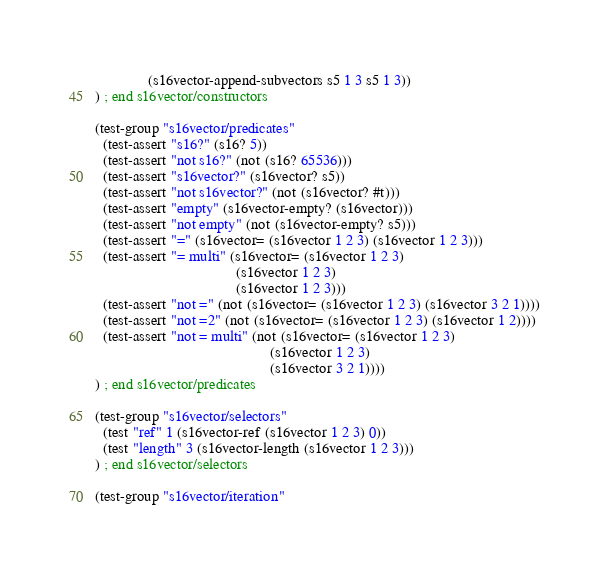Convert code to text. <code><loc_0><loc_0><loc_500><loc_500><_Scheme_>              (s16vector-append-subvectors s5 1 3 s5 1 3))
) ; end s16vector/constructors

(test-group "s16vector/predicates"
  (test-assert "s16?" (s16? 5))
  (test-assert "not s16?" (not (s16? 65536)))
  (test-assert "s16vector?" (s16vector? s5))
  (test-assert "not s16vector?" (not (s16vector? #t)))
  (test-assert "empty" (s16vector-empty? (s16vector)))
  (test-assert "not empty" (not (s16vector-empty? s5)))
  (test-assert "=" (s16vector= (s16vector 1 2 3) (s16vector 1 2 3)))
  (test-assert "= multi" (s16vector= (s16vector 1 2 3)
                                     (s16vector 1 2 3)
                                     (s16vector 1 2 3)))
  (test-assert "not =" (not (s16vector= (s16vector 1 2 3) (s16vector 3 2 1))))
  (test-assert "not =2" (not (s16vector= (s16vector 1 2 3) (s16vector 1 2))))
  (test-assert "not = multi" (not (s16vector= (s16vector 1 2 3)
                                              (s16vector 1 2 3)
                                              (s16vector 3 2 1))))
) ; end s16vector/predicates

(test-group "s16vector/selectors"
  (test "ref" 1 (s16vector-ref (s16vector 1 2 3) 0))
  (test "length" 3 (s16vector-length (s16vector 1 2 3)))
) ; end s16vector/selectors

(test-group "s16vector/iteration"</code> 